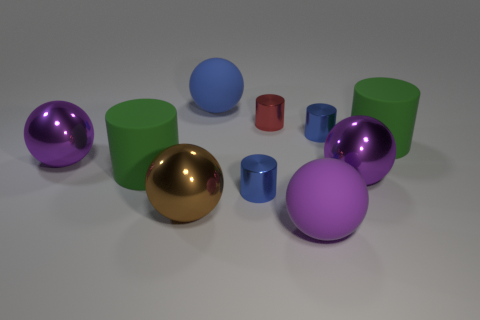Are there any other blue rubber objects of the same shape as the blue rubber thing?
Your answer should be compact. No. There is a blue metallic cylinder on the left side of the red metal cylinder; is its size the same as the large blue matte thing?
Offer a terse response. No. There is a blue object that is both to the left of the small red cylinder and on the right side of the blue sphere; what size is it?
Your response must be concise. Small. What number of other objects are there of the same material as the red object?
Your answer should be very brief. 5. There is a blue metal object to the left of the red metal cylinder; how big is it?
Your answer should be very brief. Small. What number of big objects are either balls or blue matte spheres?
Provide a short and direct response. 5. Are there any matte spheres in front of the brown metallic object?
Provide a short and direct response. Yes. There is a green object that is to the right of the blue metallic thing on the right side of the purple matte thing; what size is it?
Offer a terse response. Large. Is the number of large spheres behind the tiny red shiny cylinder the same as the number of red metal cylinders that are in front of the purple matte object?
Provide a short and direct response. No. Are there any large blue rubber things that are behind the brown shiny ball on the left side of the red cylinder?
Provide a short and direct response. Yes. 